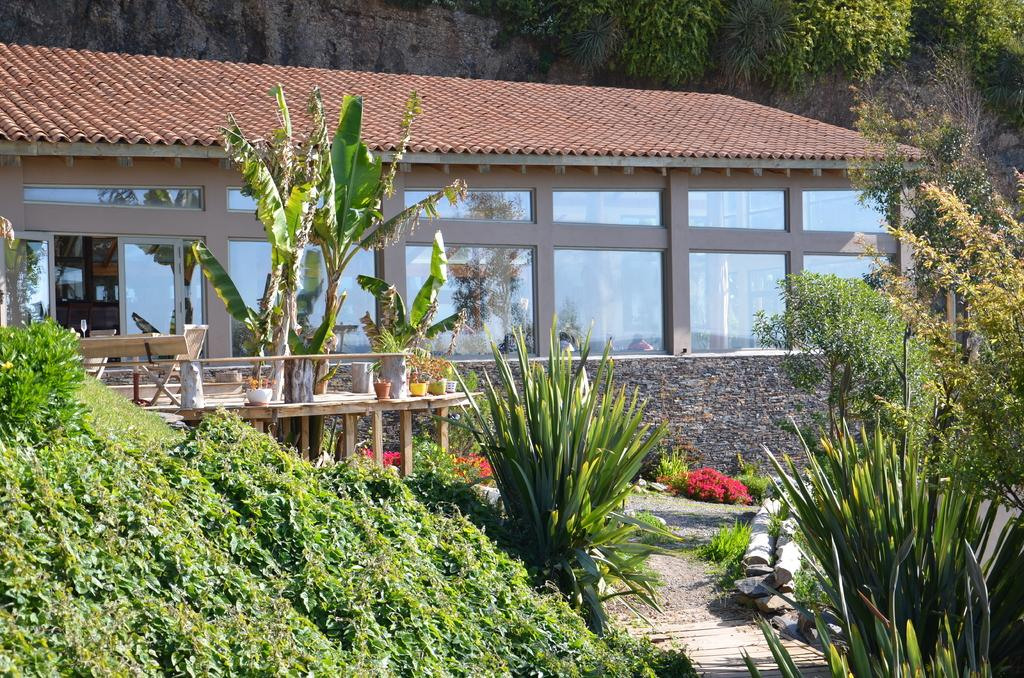What type of structure is visible in the image? There is a house in the image. What can be seen on the house? There are window glasses on the house. What type of vegetation is present in the image? There are many plants and trees in the image. What type of containers are visible in the image? There are flower pots in the image. What type of chairs can be seen in the aftermath of the dinner in the image? There is no mention of chairs, dinner, or an aftermath in the image. The image primarily features a house, window glasses, plants, trees, and flower pots. 